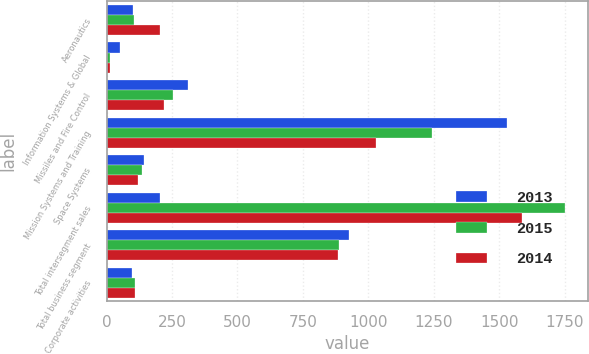Convert chart to OTSL. <chart><loc_0><loc_0><loc_500><loc_500><stacked_bar_chart><ecel><fcel>Aeronautics<fcel>Information Systems & Global<fcel>Missiles and Fire Control<fcel>Mission Systems and Training<fcel>Space Systems<fcel>Total intersegment sales<fcel>Total business segment<fcel>Corporate activities<nl><fcel>2013<fcel>102<fcel>53<fcel>313<fcel>1529<fcel>145<fcel>203<fcel>928<fcel>98<nl><fcel>2015<fcel>104<fcel>12<fcel>255<fcel>1243<fcel>136<fcel>1750<fcel>887<fcel>107<nl><fcel>2014<fcel>203<fcel>14<fcel>220<fcel>1030<fcel>119<fcel>1586<fcel>883<fcel>107<nl></chart> 